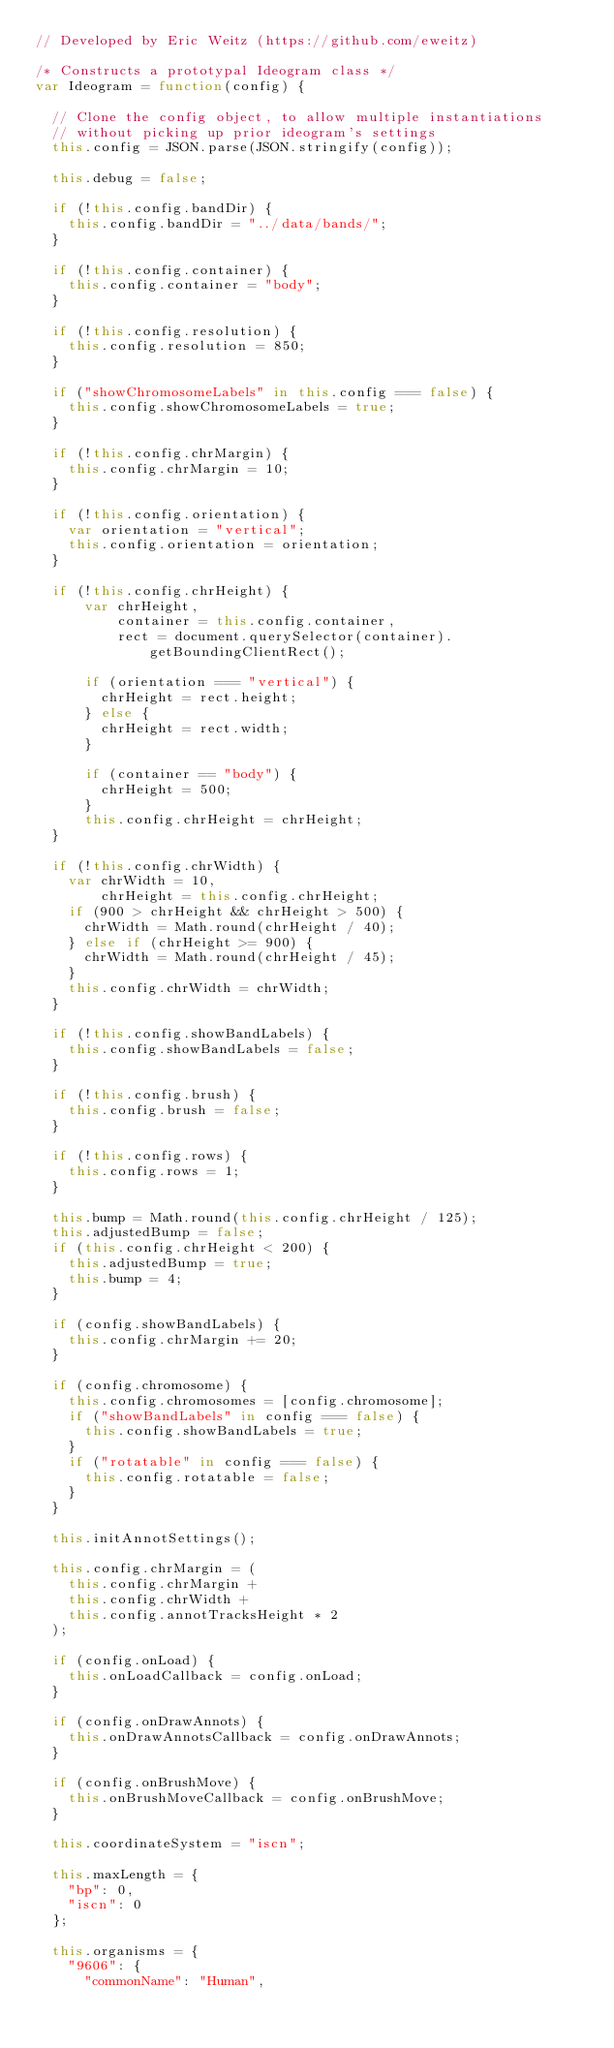<code> <loc_0><loc_0><loc_500><loc_500><_JavaScript_>// Developed by Eric Weitz (https://github.com/eweitz)

/* Constructs a prototypal Ideogram class */
var Ideogram = function(config) {

  // Clone the config object, to allow multiple instantiations
  // without picking up prior ideogram's settings
  this.config = JSON.parse(JSON.stringify(config));

  this.debug = false;

  if (!this.config.bandDir) {
    this.config.bandDir = "../data/bands/";
  }

  if (!this.config.container) {
  	this.config.container = "body";
  }

  if (!this.config.resolution) {
    this.config.resolution = 850;
  }

  if ("showChromosomeLabels" in this.config === false) {
    this.config.showChromosomeLabels = true;
  }

  if (!this.config.chrMargin) {
    this.config.chrMargin = 10;
  }

  if (!this.config.orientation) {
    var orientation = "vertical";
    this.config.orientation = orientation;
  }

  if (!this.config.chrHeight) {
      var chrHeight,
          container = this.config.container,
          rect = document.querySelector(container).getBoundingClientRect();

      if (orientation === "vertical") {
        chrHeight = rect.height;
      } else {
        chrHeight = rect.width;
      }

      if (container == "body") {
        chrHeight = 500;
      }
      this.config.chrHeight = chrHeight;
  }

  if (!this.config.chrWidth) {
    var chrWidth = 10,
        chrHeight = this.config.chrHeight;
    if (900 > chrHeight && chrHeight > 500) {
      chrWidth = Math.round(chrHeight / 40);
    } else if (chrHeight >= 900) {
      chrWidth = Math.round(chrHeight / 45);
    }
    this.config.chrWidth = chrWidth;
  }

  if (!this.config.showBandLabels) {
    this.config.showBandLabels = false;
  }

  if (!this.config.brush) {
    this.config.brush = false;
  }

  if (!this.config.rows) {
  	this.config.rows = 1;
  }

  this.bump = Math.round(this.config.chrHeight / 125);
  this.adjustedBump = false;
  if (this.config.chrHeight < 200) {
    this.adjustedBump = true;
    this.bump = 4;
  }

  if (config.showBandLabels) {
    this.config.chrMargin += 20;
  }

  if (config.chromosome) {
    this.config.chromosomes = [config.chromosome];
    if ("showBandLabels" in config === false) {
      this.config.showBandLabels = true;
    }
    if ("rotatable" in config === false) {
      this.config.rotatable = false;
    }
  }

  this.initAnnotSettings();

  this.config.chrMargin = (
    this.config.chrMargin +
    this.config.chrWidth +
    this.config.annotTracksHeight * 2
  );

  if (config.onLoad) {
    this.onLoadCallback = config.onLoad;
  }

  if (config.onDrawAnnots) {
    this.onDrawAnnotsCallback = config.onDrawAnnots;
  }

  if (config.onBrushMove) {
    this.onBrushMoveCallback = config.onBrushMove;
  }

  this.coordinateSystem = "iscn";

  this.maxLength = {
    "bp": 0,
    "iscn": 0
  };

  this.organisms = {
    "9606": {
      "commonName": "Human",</code> 